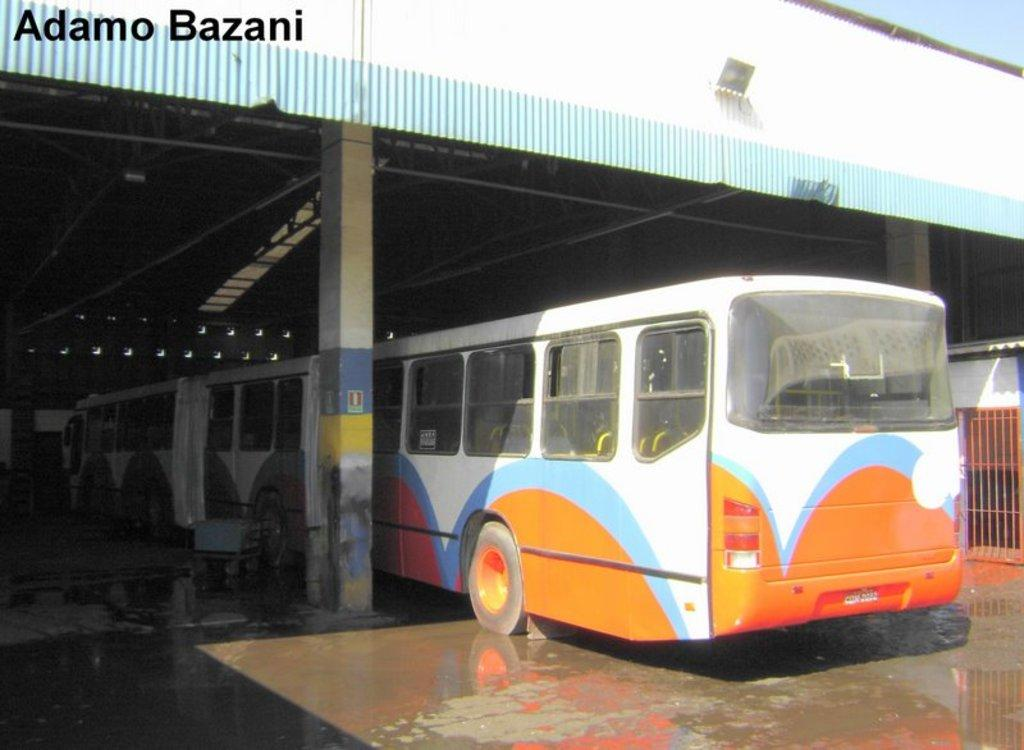What is the main subject of the picture? The main subject of the picture is a bus. What type of structure can be seen in the picture? There are iron grilles and a shed in the picture. Can you describe any additional features of the image? The image has a watermark. How many roses can be seen growing near the bus in the image? There are no roses visible in the image. Can you tell me if the person taking the picture was feeling angry? There is no information about the emotions of the person taking the picture, nor is there any indication of anger in the image itself. 